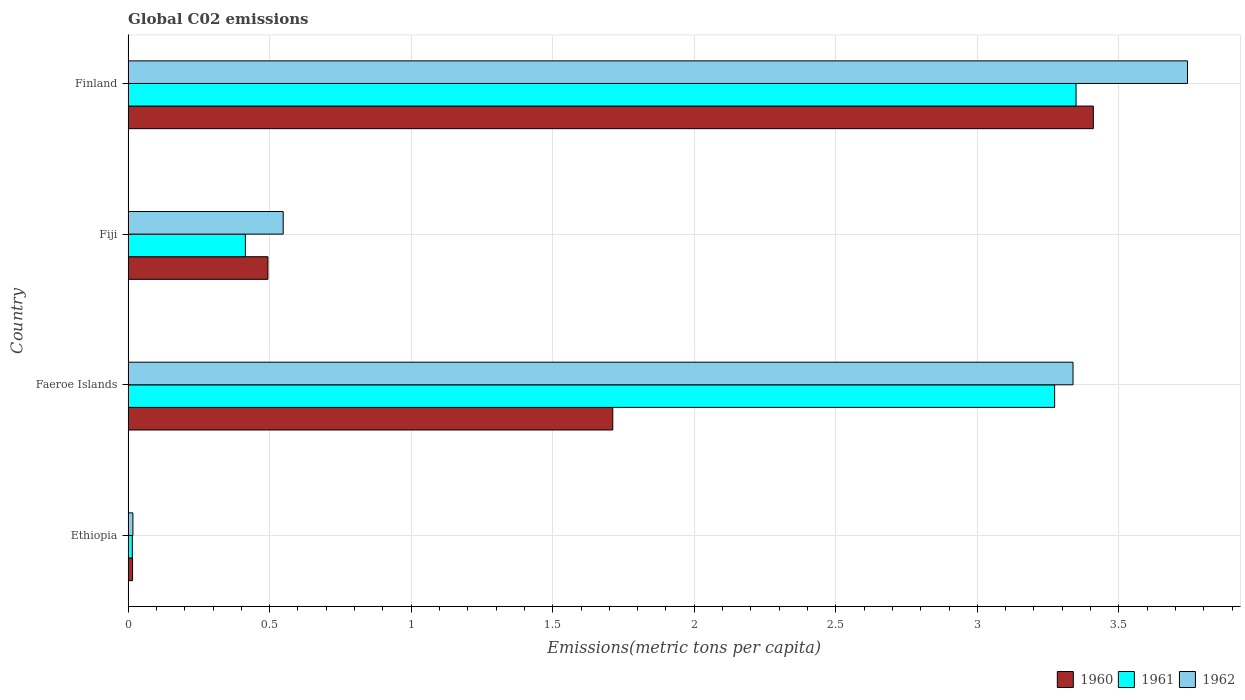How many groups of bars are there?
Make the answer very short. 4. How many bars are there on the 4th tick from the top?
Ensure brevity in your answer.  3. How many bars are there on the 4th tick from the bottom?
Make the answer very short. 3. What is the label of the 2nd group of bars from the top?
Your answer should be very brief. Fiji. What is the amount of CO2 emitted in in 1961 in Fiji?
Provide a short and direct response. 0.41. Across all countries, what is the maximum amount of CO2 emitted in in 1960?
Your response must be concise. 3.41. Across all countries, what is the minimum amount of CO2 emitted in in 1960?
Keep it short and to the point. 0.02. In which country was the amount of CO2 emitted in in 1962 minimum?
Give a very brief answer. Ethiopia. What is the total amount of CO2 emitted in in 1960 in the graph?
Offer a terse response. 5.63. What is the difference between the amount of CO2 emitted in in 1962 in Faeroe Islands and that in Fiji?
Provide a succinct answer. 2.79. What is the difference between the amount of CO2 emitted in in 1961 in Faeroe Islands and the amount of CO2 emitted in in 1962 in Finland?
Give a very brief answer. -0.47. What is the average amount of CO2 emitted in in 1960 per country?
Offer a terse response. 1.41. What is the difference between the amount of CO2 emitted in in 1962 and amount of CO2 emitted in in 1960 in Fiji?
Keep it short and to the point. 0.05. In how many countries, is the amount of CO2 emitted in in 1960 greater than 3.8 metric tons per capita?
Offer a very short reply. 0. What is the ratio of the amount of CO2 emitted in in 1962 in Fiji to that in Finland?
Keep it short and to the point. 0.15. Is the amount of CO2 emitted in in 1962 in Ethiopia less than that in Fiji?
Provide a short and direct response. Yes. Is the difference between the amount of CO2 emitted in in 1962 in Ethiopia and Faeroe Islands greater than the difference between the amount of CO2 emitted in in 1960 in Ethiopia and Faeroe Islands?
Give a very brief answer. No. What is the difference between the highest and the second highest amount of CO2 emitted in in 1962?
Keep it short and to the point. 0.4. What is the difference between the highest and the lowest amount of CO2 emitted in in 1961?
Make the answer very short. 3.33. What does the 1st bar from the bottom in Fiji represents?
Ensure brevity in your answer.  1960. Is it the case that in every country, the sum of the amount of CO2 emitted in in 1962 and amount of CO2 emitted in in 1960 is greater than the amount of CO2 emitted in in 1961?
Ensure brevity in your answer.  Yes. How many bars are there?
Offer a terse response. 12. What is the difference between two consecutive major ticks on the X-axis?
Your answer should be very brief. 0.5. Are the values on the major ticks of X-axis written in scientific E-notation?
Provide a short and direct response. No. Does the graph contain any zero values?
Keep it short and to the point. No. Does the graph contain grids?
Provide a short and direct response. Yes. Where does the legend appear in the graph?
Offer a terse response. Bottom right. How are the legend labels stacked?
Provide a succinct answer. Horizontal. What is the title of the graph?
Offer a very short reply. Global C02 emissions. Does "1973" appear as one of the legend labels in the graph?
Give a very brief answer. No. What is the label or title of the X-axis?
Offer a terse response. Emissions(metric tons per capita). What is the Emissions(metric tons per capita) in 1960 in Ethiopia?
Keep it short and to the point. 0.02. What is the Emissions(metric tons per capita) in 1961 in Ethiopia?
Your response must be concise. 0.02. What is the Emissions(metric tons per capita) in 1962 in Ethiopia?
Keep it short and to the point. 0.02. What is the Emissions(metric tons per capita) of 1960 in Faeroe Islands?
Make the answer very short. 1.71. What is the Emissions(metric tons per capita) in 1961 in Faeroe Islands?
Your response must be concise. 3.27. What is the Emissions(metric tons per capita) of 1962 in Faeroe Islands?
Your answer should be very brief. 3.34. What is the Emissions(metric tons per capita) of 1960 in Fiji?
Ensure brevity in your answer.  0.49. What is the Emissions(metric tons per capita) in 1961 in Fiji?
Provide a short and direct response. 0.41. What is the Emissions(metric tons per capita) of 1962 in Fiji?
Give a very brief answer. 0.55. What is the Emissions(metric tons per capita) in 1960 in Finland?
Provide a short and direct response. 3.41. What is the Emissions(metric tons per capita) in 1961 in Finland?
Your response must be concise. 3.35. What is the Emissions(metric tons per capita) of 1962 in Finland?
Provide a succinct answer. 3.74. Across all countries, what is the maximum Emissions(metric tons per capita) in 1960?
Ensure brevity in your answer.  3.41. Across all countries, what is the maximum Emissions(metric tons per capita) in 1961?
Ensure brevity in your answer.  3.35. Across all countries, what is the maximum Emissions(metric tons per capita) in 1962?
Offer a terse response. 3.74. Across all countries, what is the minimum Emissions(metric tons per capita) of 1960?
Give a very brief answer. 0.02. Across all countries, what is the minimum Emissions(metric tons per capita) of 1961?
Your answer should be compact. 0.02. Across all countries, what is the minimum Emissions(metric tons per capita) of 1962?
Make the answer very short. 0.02. What is the total Emissions(metric tons per capita) of 1960 in the graph?
Offer a terse response. 5.63. What is the total Emissions(metric tons per capita) of 1961 in the graph?
Your answer should be very brief. 7.05. What is the total Emissions(metric tons per capita) in 1962 in the graph?
Offer a terse response. 7.65. What is the difference between the Emissions(metric tons per capita) of 1960 in Ethiopia and that in Faeroe Islands?
Your response must be concise. -1.7. What is the difference between the Emissions(metric tons per capita) of 1961 in Ethiopia and that in Faeroe Islands?
Make the answer very short. -3.26. What is the difference between the Emissions(metric tons per capita) in 1962 in Ethiopia and that in Faeroe Islands?
Provide a short and direct response. -3.32. What is the difference between the Emissions(metric tons per capita) in 1960 in Ethiopia and that in Fiji?
Your answer should be compact. -0.48. What is the difference between the Emissions(metric tons per capita) of 1961 in Ethiopia and that in Fiji?
Keep it short and to the point. -0.4. What is the difference between the Emissions(metric tons per capita) of 1962 in Ethiopia and that in Fiji?
Provide a succinct answer. -0.53. What is the difference between the Emissions(metric tons per capita) in 1960 in Ethiopia and that in Finland?
Keep it short and to the point. -3.39. What is the difference between the Emissions(metric tons per capita) in 1961 in Ethiopia and that in Finland?
Keep it short and to the point. -3.33. What is the difference between the Emissions(metric tons per capita) of 1962 in Ethiopia and that in Finland?
Provide a short and direct response. -3.73. What is the difference between the Emissions(metric tons per capita) in 1960 in Faeroe Islands and that in Fiji?
Offer a very short reply. 1.22. What is the difference between the Emissions(metric tons per capita) in 1961 in Faeroe Islands and that in Fiji?
Provide a succinct answer. 2.86. What is the difference between the Emissions(metric tons per capita) in 1962 in Faeroe Islands and that in Fiji?
Provide a succinct answer. 2.79. What is the difference between the Emissions(metric tons per capita) in 1960 in Faeroe Islands and that in Finland?
Your answer should be compact. -1.7. What is the difference between the Emissions(metric tons per capita) of 1961 in Faeroe Islands and that in Finland?
Offer a terse response. -0.08. What is the difference between the Emissions(metric tons per capita) of 1962 in Faeroe Islands and that in Finland?
Offer a very short reply. -0.4. What is the difference between the Emissions(metric tons per capita) in 1960 in Fiji and that in Finland?
Give a very brief answer. -2.92. What is the difference between the Emissions(metric tons per capita) in 1961 in Fiji and that in Finland?
Give a very brief answer. -2.93. What is the difference between the Emissions(metric tons per capita) in 1962 in Fiji and that in Finland?
Your answer should be compact. -3.19. What is the difference between the Emissions(metric tons per capita) in 1960 in Ethiopia and the Emissions(metric tons per capita) in 1961 in Faeroe Islands?
Make the answer very short. -3.26. What is the difference between the Emissions(metric tons per capita) of 1960 in Ethiopia and the Emissions(metric tons per capita) of 1962 in Faeroe Islands?
Provide a succinct answer. -3.32. What is the difference between the Emissions(metric tons per capita) of 1961 in Ethiopia and the Emissions(metric tons per capita) of 1962 in Faeroe Islands?
Keep it short and to the point. -3.32. What is the difference between the Emissions(metric tons per capita) of 1960 in Ethiopia and the Emissions(metric tons per capita) of 1961 in Fiji?
Give a very brief answer. -0.4. What is the difference between the Emissions(metric tons per capita) of 1960 in Ethiopia and the Emissions(metric tons per capita) of 1962 in Fiji?
Provide a succinct answer. -0.53. What is the difference between the Emissions(metric tons per capita) of 1961 in Ethiopia and the Emissions(metric tons per capita) of 1962 in Fiji?
Ensure brevity in your answer.  -0.53. What is the difference between the Emissions(metric tons per capita) of 1960 in Ethiopia and the Emissions(metric tons per capita) of 1961 in Finland?
Your response must be concise. -3.33. What is the difference between the Emissions(metric tons per capita) of 1960 in Ethiopia and the Emissions(metric tons per capita) of 1962 in Finland?
Offer a very short reply. -3.73. What is the difference between the Emissions(metric tons per capita) in 1961 in Ethiopia and the Emissions(metric tons per capita) in 1962 in Finland?
Ensure brevity in your answer.  -3.73. What is the difference between the Emissions(metric tons per capita) of 1960 in Faeroe Islands and the Emissions(metric tons per capita) of 1961 in Fiji?
Ensure brevity in your answer.  1.3. What is the difference between the Emissions(metric tons per capita) in 1960 in Faeroe Islands and the Emissions(metric tons per capita) in 1962 in Fiji?
Provide a short and direct response. 1.16. What is the difference between the Emissions(metric tons per capita) of 1961 in Faeroe Islands and the Emissions(metric tons per capita) of 1962 in Fiji?
Keep it short and to the point. 2.73. What is the difference between the Emissions(metric tons per capita) in 1960 in Faeroe Islands and the Emissions(metric tons per capita) in 1961 in Finland?
Keep it short and to the point. -1.64. What is the difference between the Emissions(metric tons per capita) in 1960 in Faeroe Islands and the Emissions(metric tons per capita) in 1962 in Finland?
Ensure brevity in your answer.  -2.03. What is the difference between the Emissions(metric tons per capita) in 1961 in Faeroe Islands and the Emissions(metric tons per capita) in 1962 in Finland?
Your answer should be compact. -0.47. What is the difference between the Emissions(metric tons per capita) in 1960 in Fiji and the Emissions(metric tons per capita) in 1961 in Finland?
Give a very brief answer. -2.85. What is the difference between the Emissions(metric tons per capita) in 1960 in Fiji and the Emissions(metric tons per capita) in 1962 in Finland?
Your answer should be very brief. -3.25. What is the difference between the Emissions(metric tons per capita) of 1961 in Fiji and the Emissions(metric tons per capita) of 1962 in Finland?
Offer a very short reply. -3.33. What is the average Emissions(metric tons per capita) of 1960 per country?
Give a very brief answer. 1.41. What is the average Emissions(metric tons per capita) of 1961 per country?
Your answer should be very brief. 1.76. What is the average Emissions(metric tons per capita) of 1962 per country?
Your answer should be very brief. 1.91. What is the difference between the Emissions(metric tons per capita) in 1960 and Emissions(metric tons per capita) in 1961 in Ethiopia?
Your answer should be compact. 0. What is the difference between the Emissions(metric tons per capita) in 1960 and Emissions(metric tons per capita) in 1962 in Ethiopia?
Provide a succinct answer. -0. What is the difference between the Emissions(metric tons per capita) of 1961 and Emissions(metric tons per capita) of 1962 in Ethiopia?
Your answer should be very brief. -0. What is the difference between the Emissions(metric tons per capita) in 1960 and Emissions(metric tons per capita) in 1961 in Faeroe Islands?
Make the answer very short. -1.56. What is the difference between the Emissions(metric tons per capita) in 1960 and Emissions(metric tons per capita) in 1962 in Faeroe Islands?
Your response must be concise. -1.63. What is the difference between the Emissions(metric tons per capita) of 1961 and Emissions(metric tons per capita) of 1962 in Faeroe Islands?
Your answer should be compact. -0.06. What is the difference between the Emissions(metric tons per capita) in 1960 and Emissions(metric tons per capita) in 1961 in Fiji?
Your answer should be compact. 0.08. What is the difference between the Emissions(metric tons per capita) in 1960 and Emissions(metric tons per capita) in 1962 in Fiji?
Offer a terse response. -0.05. What is the difference between the Emissions(metric tons per capita) of 1961 and Emissions(metric tons per capita) of 1962 in Fiji?
Your response must be concise. -0.13. What is the difference between the Emissions(metric tons per capita) in 1960 and Emissions(metric tons per capita) in 1961 in Finland?
Provide a short and direct response. 0.06. What is the difference between the Emissions(metric tons per capita) in 1960 and Emissions(metric tons per capita) in 1962 in Finland?
Your answer should be very brief. -0.33. What is the difference between the Emissions(metric tons per capita) in 1961 and Emissions(metric tons per capita) in 1962 in Finland?
Make the answer very short. -0.39. What is the ratio of the Emissions(metric tons per capita) of 1960 in Ethiopia to that in Faeroe Islands?
Your answer should be very brief. 0.01. What is the ratio of the Emissions(metric tons per capita) of 1961 in Ethiopia to that in Faeroe Islands?
Keep it short and to the point. 0. What is the ratio of the Emissions(metric tons per capita) of 1962 in Ethiopia to that in Faeroe Islands?
Offer a very short reply. 0.01. What is the ratio of the Emissions(metric tons per capita) of 1960 in Ethiopia to that in Fiji?
Keep it short and to the point. 0.03. What is the ratio of the Emissions(metric tons per capita) in 1961 in Ethiopia to that in Fiji?
Keep it short and to the point. 0.04. What is the ratio of the Emissions(metric tons per capita) of 1962 in Ethiopia to that in Fiji?
Your response must be concise. 0.03. What is the ratio of the Emissions(metric tons per capita) in 1960 in Ethiopia to that in Finland?
Provide a succinct answer. 0. What is the ratio of the Emissions(metric tons per capita) of 1961 in Ethiopia to that in Finland?
Offer a very short reply. 0. What is the ratio of the Emissions(metric tons per capita) in 1962 in Ethiopia to that in Finland?
Provide a short and direct response. 0. What is the ratio of the Emissions(metric tons per capita) in 1960 in Faeroe Islands to that in Fiji?
Ensure brevity in your answer.  3.47. What is the ratio of the Emissions(metric tons per capita) in 1961 in Faeroe Islands to that in Fiji?
Make the answer very short. 7.9. What is the ratio of the Emissions(metric tons per capita) of 1962 in Faeroe Islands to that in Fiji?
Ensure brevity in your answer.  6.09. What is the ratio of the Emissions(metric tons per capita) of 1960 in Faeroe Islands to that in Finland?
Ensure brevity in your answer.  0.5. What is the ratio of the Emissions(metric tons per capita) in 1961 in Faeroe Islands to that in Finland?
Offer a very short reply. 0.98. What is the ratio of the Emissions(metric tons per capita) in 1962 in Faeroe Islands to that in Finland?
Your response must be concise. 0.89. What is the ratio of the Emissions(metric tons per capita) of 1960 in Fiji to that in Finland?
Provide a succinct answer. 0.14. What is the ratio of the Emissions(metric tons per capita) in 1961 in Fiji to that in Finland?
Your answer should be compact. 0.12. What is the ratio of the Emissions(metric tons per capita) of 1962 in Fiji to that in Finland?
Your answer should be very brief. 0.15. What is the difference between the highest and the second highest Emissions(metric tons per capita) in 1960?
Provide a succinct answer. 1.7. What is the difference between the highest and the second highest Emissions(metric tons per capita) of 1961?
Your response must be concise. 0.08. What is the difference between the highest and the second highest Emissions(metric tons per capita) in 1962?
Ensure brevity in your answer.  0.4. What is the difference between the highest and the lowest Emissions(metric tons per capita) in 1960?
Offer a terse response. 3.39. What is the difference between the highest and the lowest Emissions(metric tons per capita) in 1961?
Provide a succinct answer. 3.33. What is the difference between the highest and the lowest Emissions(metric tons per capita) of 1962?
Make the answer very short. 3.73. 